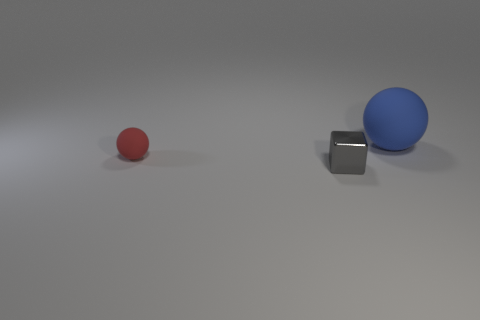Is the number of tiny gray metallic cubes to the left of the red sphere less than the number of small rubber objects that are to the right of the blue ball?
Ensure brevity in your answer.  No. What number of other objects are the same material as the gray thing?
Your answer should be very brief. 0. What material is the red thing that is the same size as the cube?
Offer a terse response. Rubber. How many gray things are either cubes or tiny rubber spheres?
Your response must be concise. 1. There is a object that is both in front of the blue object and on the right side of the small ball; what is its color?
Provide a succinct answer. Gray. Does the thing that is on the left side of the metallic object have the same material as the small cube on the left side of the big blue rubber sphere?
Offer a very short reply. No. Are there more things that are on the left side of the gray thing than tiny cubes that are behind the red ball?
Ensure brevity in your answer.  Yes. There is a gray object that is the same size as the red rubber object; what shape is it?
Keep it short and to the point. Cube. How many objects are large blue metallic objects or things that are left of the blue matte sphere?
Offer a very short reply. 2. Is the color of the small cube the same as the big rubber object?
Your response must be concise. No. 